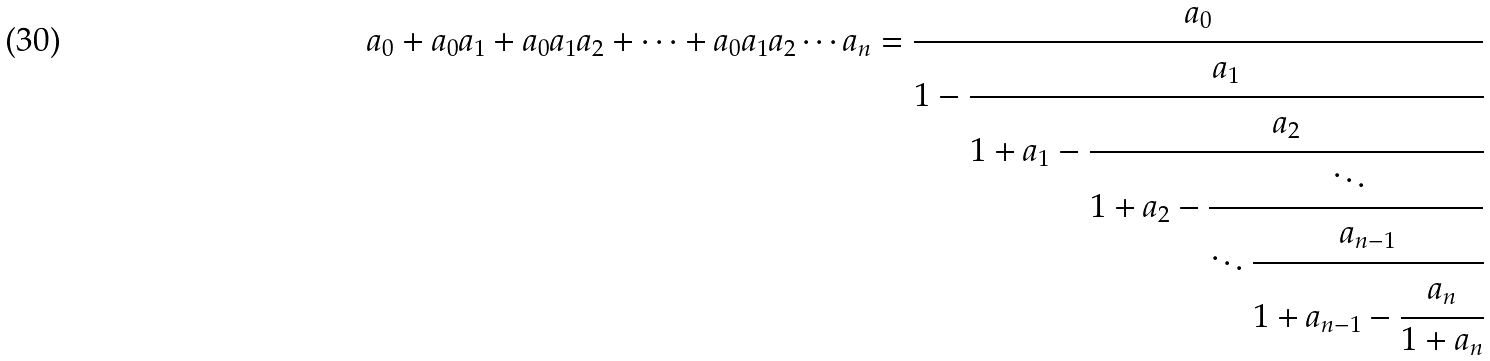<formula> <loc_0><loc_0><loc_500><loc_500>a _ { 0 } + a _ { 0 } a _ { 1 } + a _ { 0 } a _ { 1 } a _ { 2 } + \cdots + a _ { 0 } a _ { 1 } a _ { 2 } \cdots a _ { n } = { \cfrac { a _ { 0 } } { 1 - { \cfrac { a _ { 1 } } { 1 + a _ { 1 } - { \cfrac { a _ { 2 } } { 1 + a _ { 2 } - { \cfrac { \ddots } { \ddots { \cfrac { a _ { n - 1 } } { 1 + a _ { n - 1 } - { \cfrac { a _ { n } } { 1 + a _ { n } } } } } } } } } } } } }</formula> 